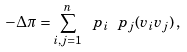Convert formula to latex. <formula><loc_0><loc_0><loc_500><loc_500>- \Delta \pi = \sum _ { i , j = 1 } ^ { n } \ p _ { i } \ p _ { j } ( v _ { i } v _ { j } ) \, ,</formula> 